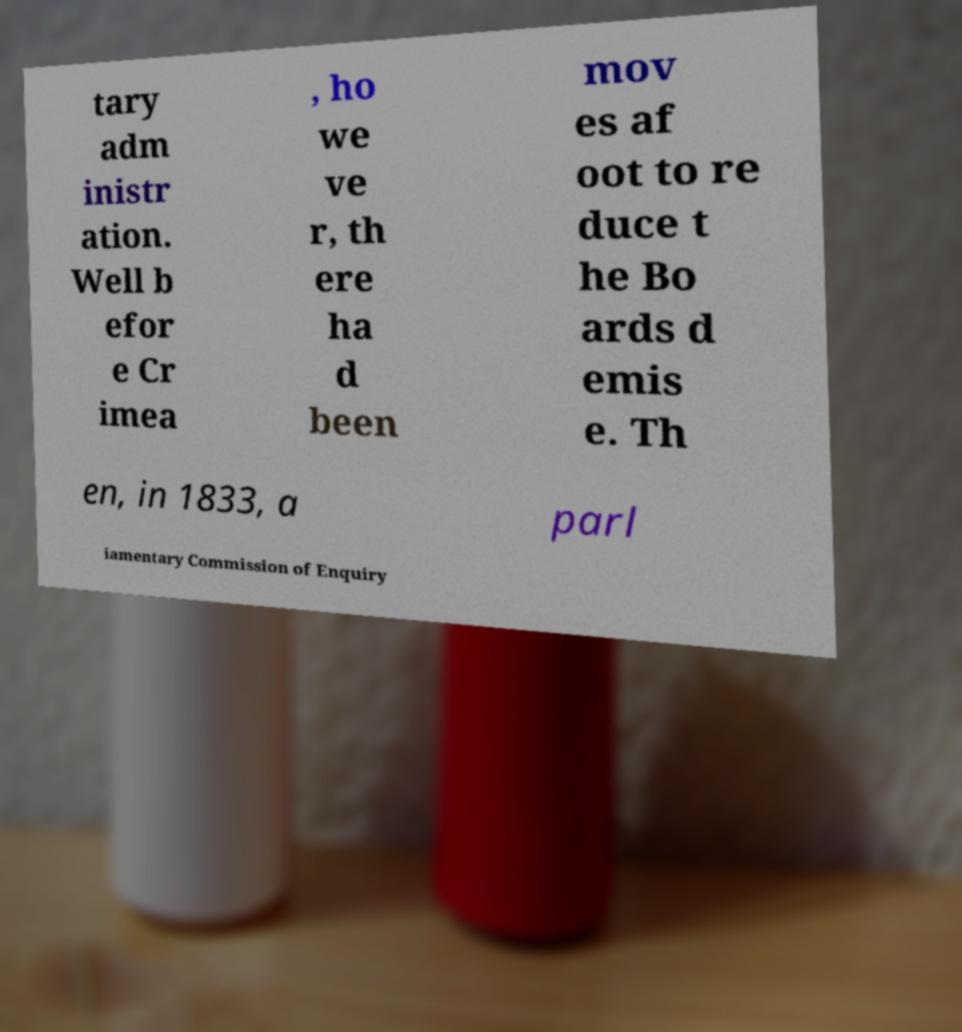Can you accurately transcribe the text from the provided image for me? tary adm inistr ation. Well b efor e Cr imea , ho we ve r, th ere ha d been mov es af oot to re duce t he Bo ards d emis e. Th en, in 1833, a parl iamentary Commission of Enquiry 